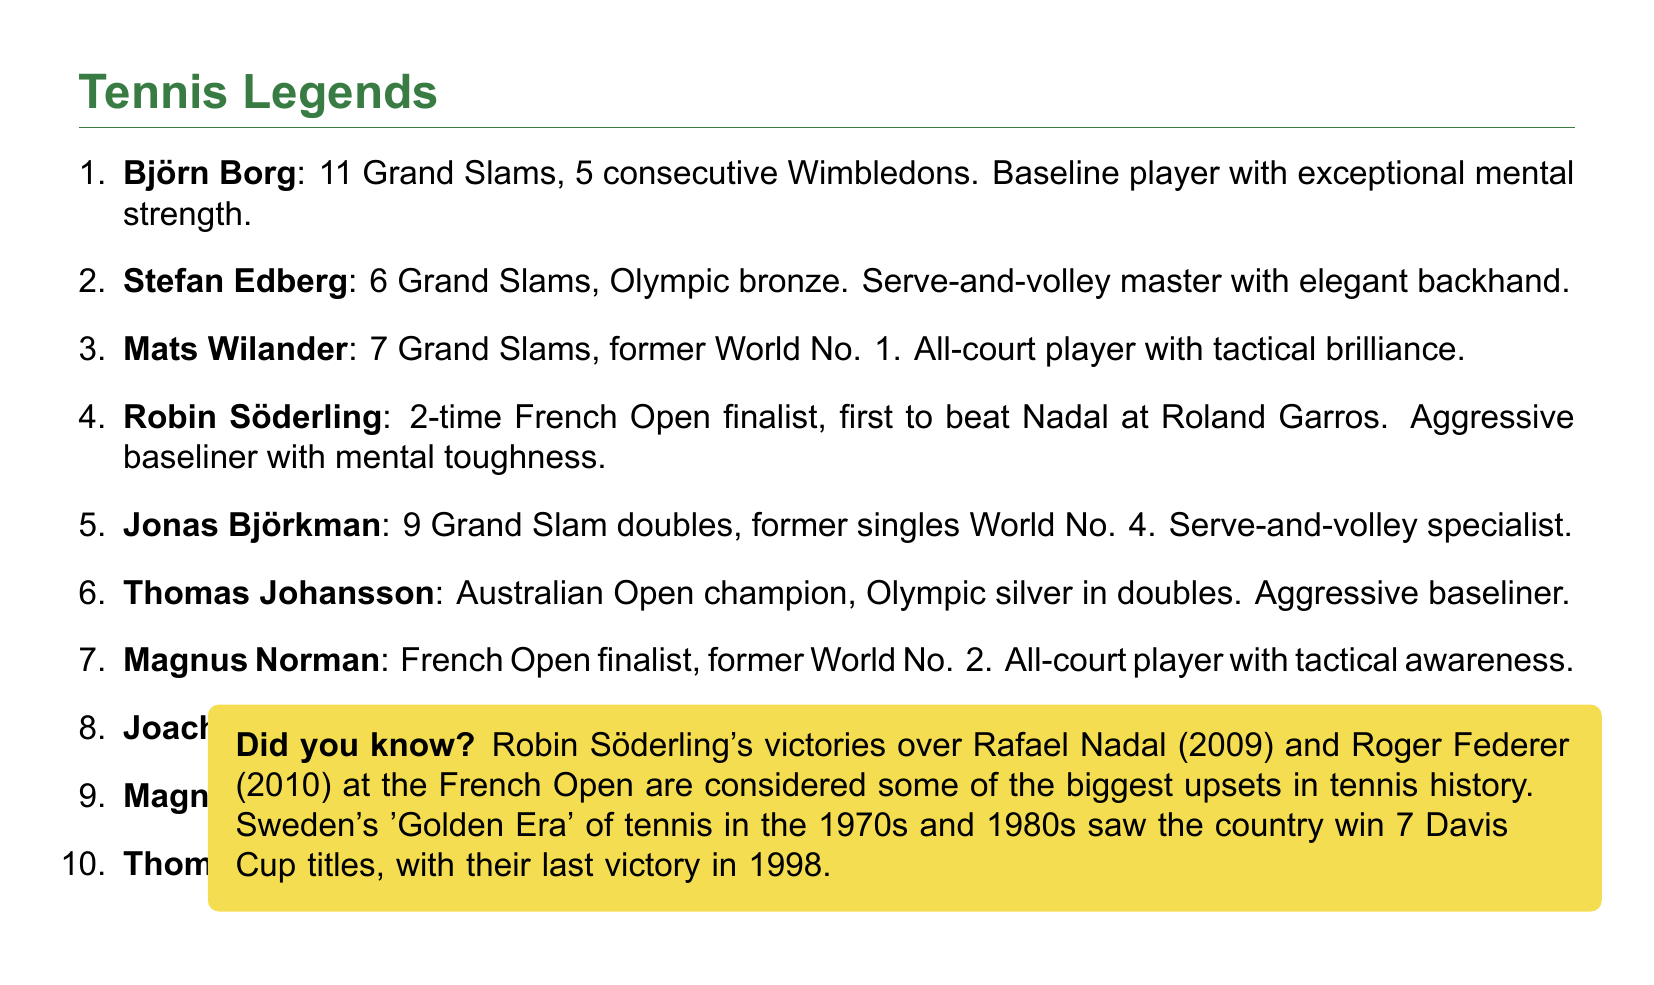What is the total number of Grand Slam singles titles won by Björn Borg? Björn Borg won 11 Grand Slam singles titles, as mentioned in the achievements list.
Answer: 11 Which player was the first to defeat Rafael Nadal at the French Open? Robin Söderling is noted as the first player to defeat Rafael Nadal at the French Open in 2009.
Answer: Robin Söderling How many ATP singles titles did Magnus Gustafsson win? Magnus Gustafsson won 14 ATP singles titles, as outlined in his achievements.
Answer: 14 What is Robin Söderling's career-high ranking? The document states that Robin Söderling reached a career-high ranking of World No. 4.
Answer: World No. 4 Who was an Olympic bronze medalist in singles? Stefan Edberg is identified as the Olympic bronze medalist in singles in 1988.
Answer: Stefan Edberg What playing style is associated with Mats Wilander? Mats Wilander's playing style is described as an all-court player with tactical brilliance.
Answer: All-court player How many Davis Cup titles has Sweden won? The document mentions that Sweden has won the Davis Cup 7 times.
Answer: 7 Which player was an Australian Open champion in 2002? Thomas Johansson is noted as the Australian Open champion in 2002.
Answer: Thomas Johansson What unique achievement is highlighted about Robin Söderling in relation to major upsets? Robin Söderling's victories over Rafael Nadal and Roger Federer at the French Open are highlighted as major upsets in tennis history.
Answer: Major upsets What is the unique title attributed to the 1970s and 1980s in Swedish tennis history? The 1970s and 1980s are referred to as the 'Golden Era' of Swedish tennis.
Answer: Golden Era 